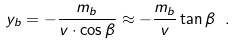Convert formula to latex. <formula><loc_0><loc_0><loc_500><loc_500>y _ { b } = - \frac { m _ { b } } { v \cdot \cos \beta } \approx - \frac { m _ { b } } { v } \tan \beta \ .</formula> 